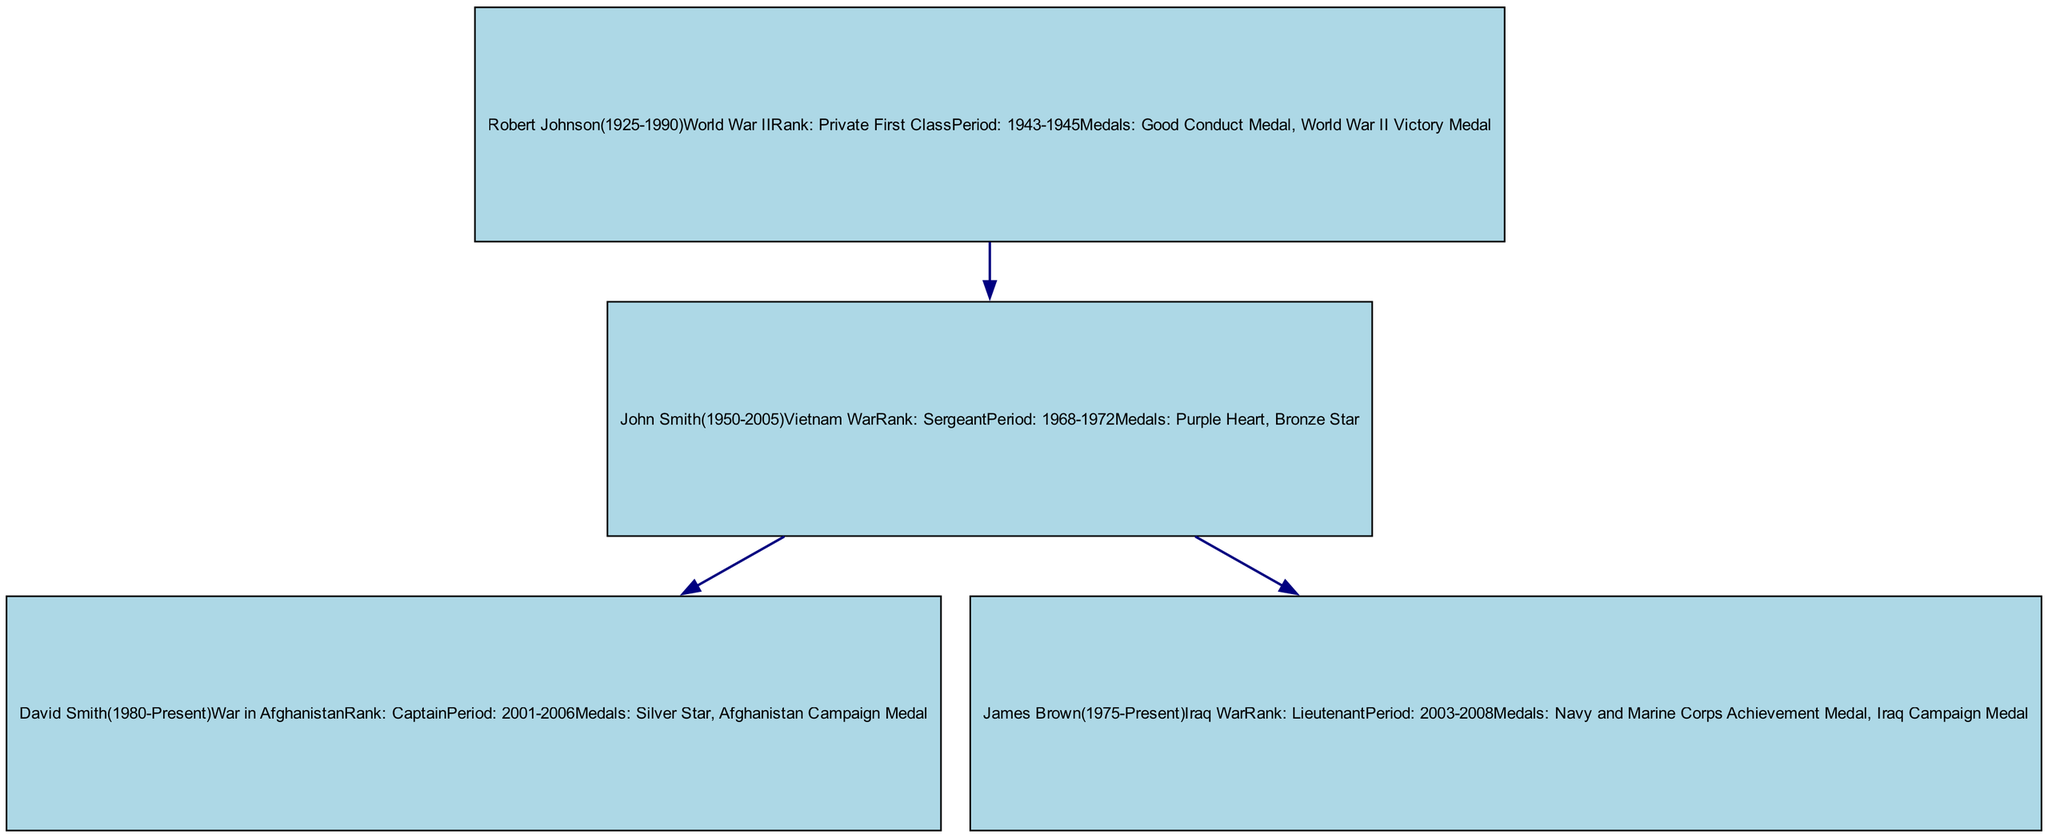What is the rank achieved by John Smith? The diagram indicates that John Smith achieved the rank of Sergeant during his military service, specifically in the Vietnam War.
Answer: Sergeant How many medals did David Smith receive? From the diagram, David Smith received two medals during his service in the War in Afghanistan: Silver Star and Afghanistan Campaign Medal.
Answer: 2 Which war did Robert Johnson fight in? The diagram specifies that Robert Johnson fought in World War II as indicated in his military service information.
Answer: World War II Who is the father of David Smith? The diagram shows that John Smith is the parent of David Smith, as indicated by the edges connecting them.
Answer: John Smith What was the service period of James Brown? According to the diagram, James Brown served in the Iraq War from 2003 to 2008.
Answer: 2003-2008 Which medal was awarded to John Smith? The diagram states that John Smith was awarded the Purple Heart and Bronze Star for his service in the Vietnam War.
Answer: Purple Heart, Bronze Star How many individuals in the family tree served in the military? By reviewing the diagram, there are four individuals in the family tree who have military service records: John Smith, David Smith, Robert Johnson, and James Brown.
Answer: 4 What is the relationship between Robert Johnson and John Smith? The diagram shows that Robert Johnson is the father of John Smith, which is represented by the edge connecting them.
Answer: Father Which historical event is associated with James Brown's military service? The diagram indicates that James Brown served during the Iraq War, which is identified in his military service record.
Answer: Iraq War 